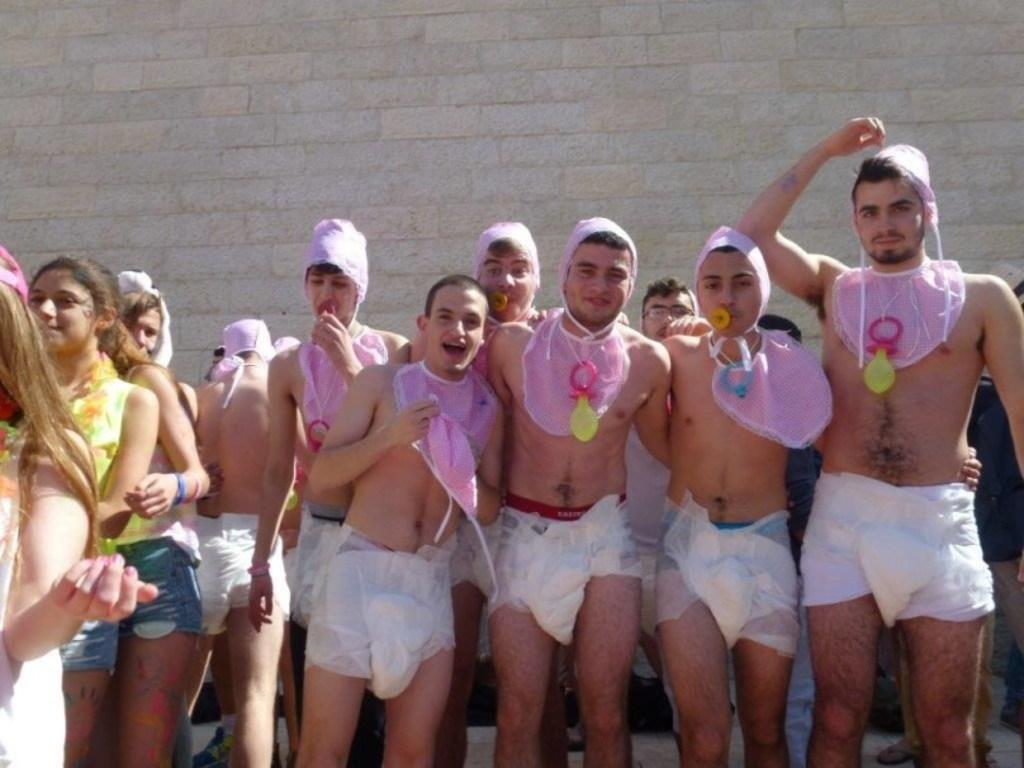How many people are in the group visible in the image? The number of people in the group cannot be determined from the provided facts. What is located behind the persons in the image? There is a wall visible behind the persons in the image. What type of animal can be seen climbing the wall in the image? There is no animal visible in the image, and therefore no such activity can be observed. 